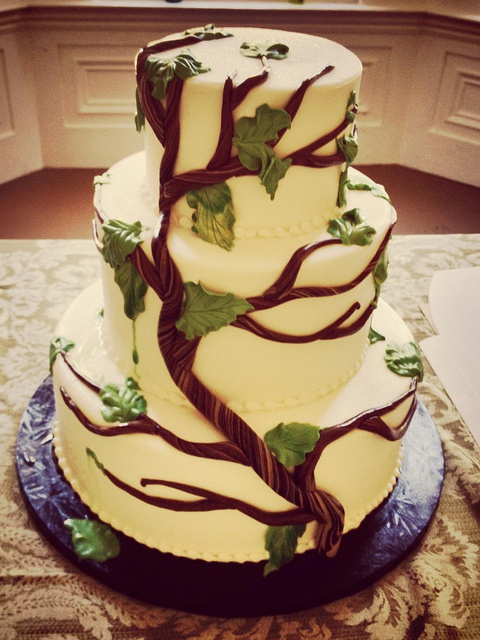Describe the objects in this image and their specific colors. I can see a cake in gray, tan, maroon, and olive tones in this image. 